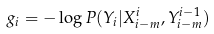<formula> <loc_0><loc_0><loc_500><loc_500>g _ { i } = - \log P ( Y _ { i } | X ^ { i } _ { i - m } , Y ^ { i - 1 } _ { i - m } )</formula> 